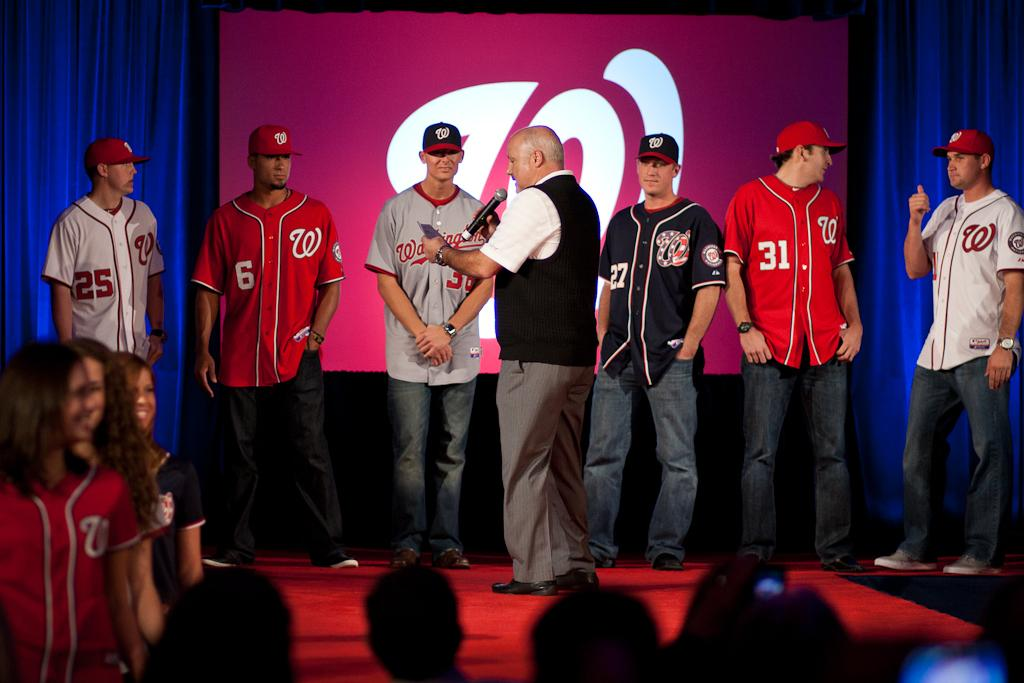<image>
Share a concise interpretation of the image provided. Ballplayers with numbers like 6, 25, 31 and 27 stand on a stage with a man holding a microphone. 